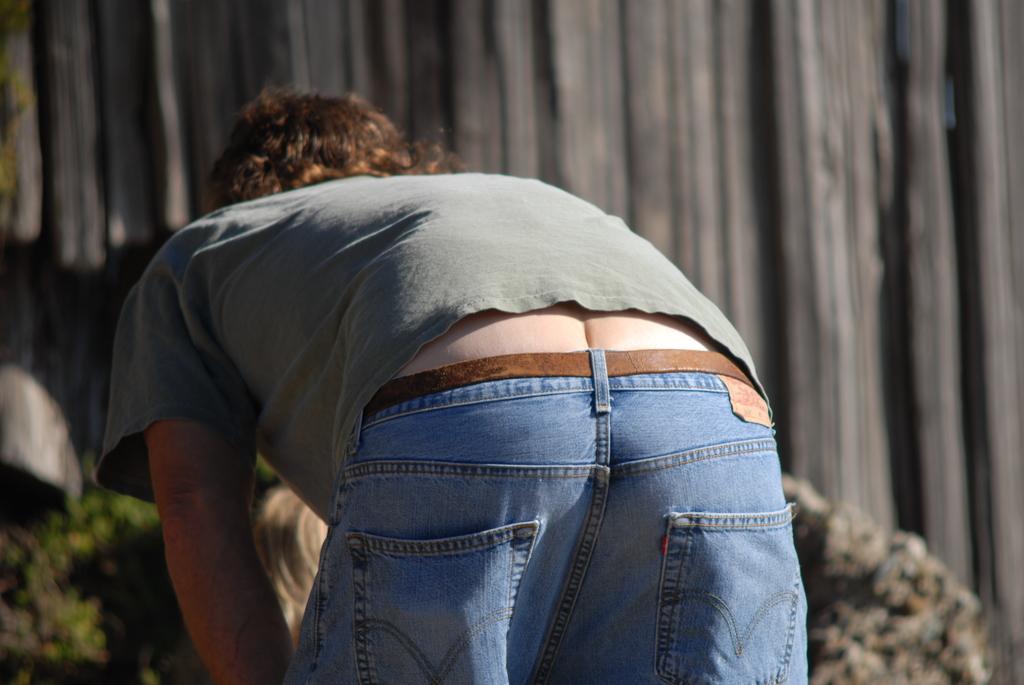Could you give a brief overview of what you see in this image? In this image we can see a person and in the background, we can see the wall, also we can see there are some blurred objects. 